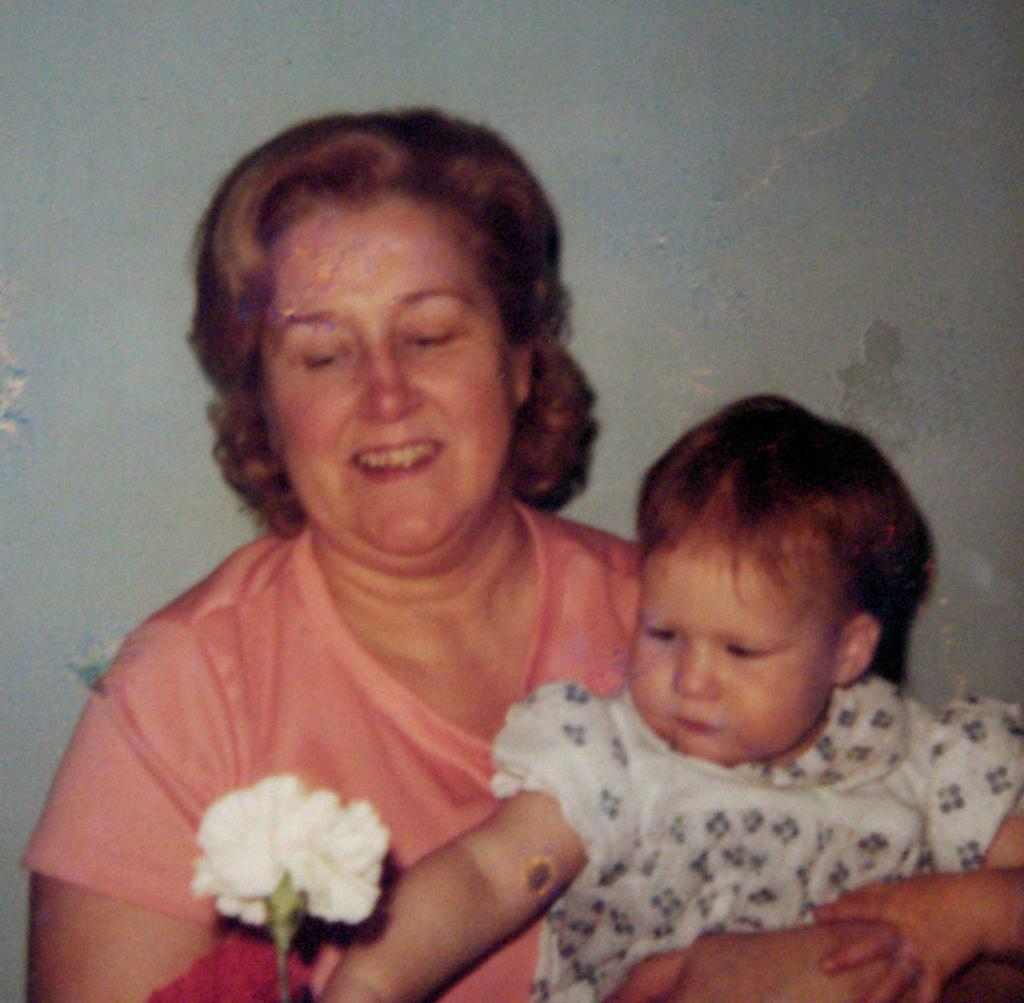Who is the main subject in the image? There is a woman in the image. What is the woman doing in the image? The woman is holding a kid. What can be seen at the bottom of the image? There is a flower at the bottom of the image. What is visible in the background of the image? There is a wall in the background of the image. What type of plant is the woman talking to in the image? There is no plant present in the image, and the woman is not talking to anyone or anything. 